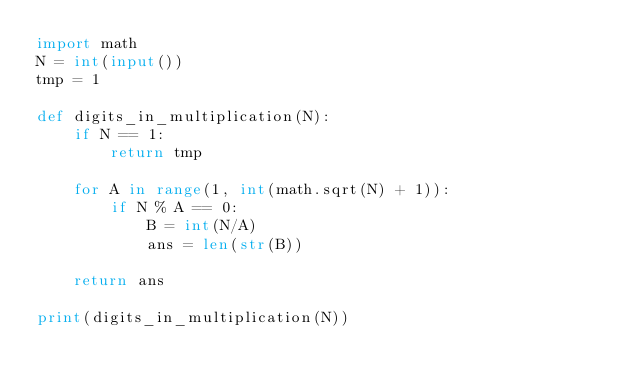Convert code to text. <code><loc_0><loc_0><loc_500><loc_500><_Python_>import math
N = int(input())
tmp = 1

def digits_in_multiplication(N):
    if N == 1:
        return tmp

    for A in range(1, int(math.sqrt(N) + 1)):
        if N % A == 0:
            B = int(N/A)
            ans = len(str(B))

    return ans

print(digits_in_multiplication(N))</code> 